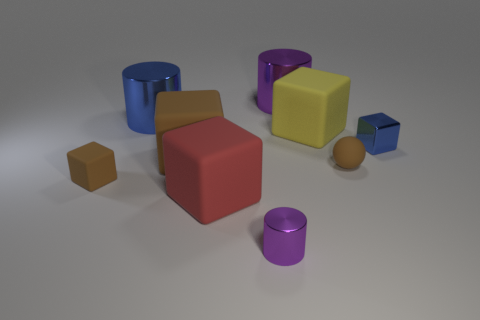There is a small brown thing that is the same shape as the big brown thing; what is it made of?
Offer a very short reply. Rubber. What is the large yellow object made of?
Your response must be concise. Rubber. There is a brown thing that is the same size as the red matte cube; what is it made of?
Provide a succinct answer. Rubber. Are the large purple cylinder and the big cube to the right of the small shiny cylinder made of the same material?
Your response must be concise. No. What is the material of the big thing that is the same color as the rubber ball?
Provide a succinct answer. Rubber. What number of shiny objects have the same color as the small rubber ball?
Give a very brief answer. 0. What size is the red thing?
Your answer should be compact. Large. There is a big brown matte thing; does it have the same shape as the large metallic thing left of the red matte object?
Keep it short and to the point. No. There is a tiny object that is the same material as the tiny blue block; what color is it?
Give a very brief answer. Purple. What size is the rubber cube to the right of the small cylinder?
Make the answer very short. Large. 